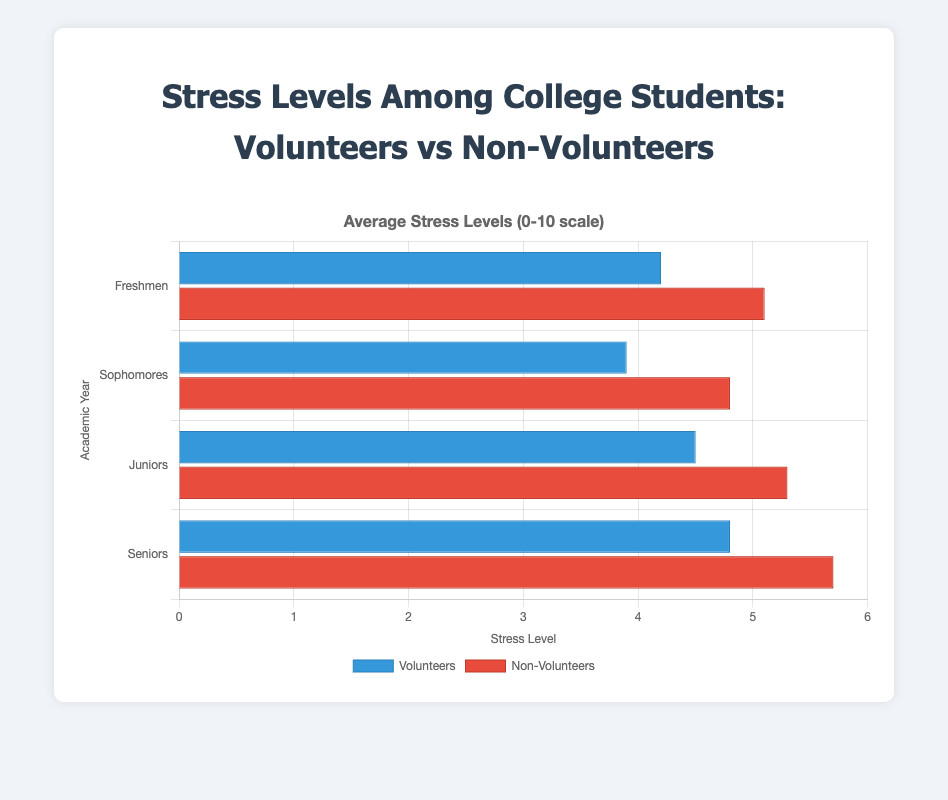What is the average stress level among Juniors? To find the average stress level among Juniors, we take the stress levels of both Volunteers and Non-Volunteers and compute the average: (4.5 (Volunteers) + 5.3 (Non-Volunteers)) / 2. Therefore, the average stress level among Juniors is (4.5 + 5.3) / 2 = 4.9
Answer: 4.9 Which group has a higher average stress level: Volunteers or Non-Volunteers? To find out which group has a higher average stress level, we first find the average for each group. Volunteers: (4.2 + 3.9 + 4.5 + 4.8) / 4 = 4.35, Non-Volunteers: (5.1 + 4.8 + 5.3 + 5.7) / 4 = 5.225. Comparing the two, Non-Volunteers have a higher average stress level of 5.225 compared to 4.35 for Volunteers
Answer: Non-Volunteers How much higher is the stress level of Seniors who do not volunteer compared to those who do? To find the difference in stress levels between non-volunteering and volunteering Seniors, we subtract the stress level of volunteering Seniors from that of non-volunteering Seniors: 5.7 - 4.8. Therefore, the difference is 5.7 - 4.8 = 0.9
Answer: 0.9 Which group has the highest stress level among all academic years? To find the group with the highest stress level, we look at the highest data points in the chart for both groups. Volunteers: 4.8 (Seniors), Non-Volunteers: 5.7 (Seniors). Hence, Non-Volunteer Seniors have the highest stress level of 5.7.
Answer: Non-Volunteer Seniors What is the total stress level for all Non-Volunteer students? To find the total stress level for all Non-Volunteers, we sum their stress levels: 5.1 (Freshmen) + 4.8 (Sophomores) + 5.3 (Juniors) + 5.7 (Seniors). The total stress level is 5.1 + 4.8 + 5.3 + 5.7 = 20.9.
Answer: 20.9 Which academic year has the lowest stress level among Volunteers? To identify the year with the lowest stress level among Volunteers, we examine the values: Freshmen (4.2), Sophomores (3.9), Juniors (4.5), Seniors (4.8). The lowest stress level is for Sophomores, which is 3.9
Answer: Sophomores 